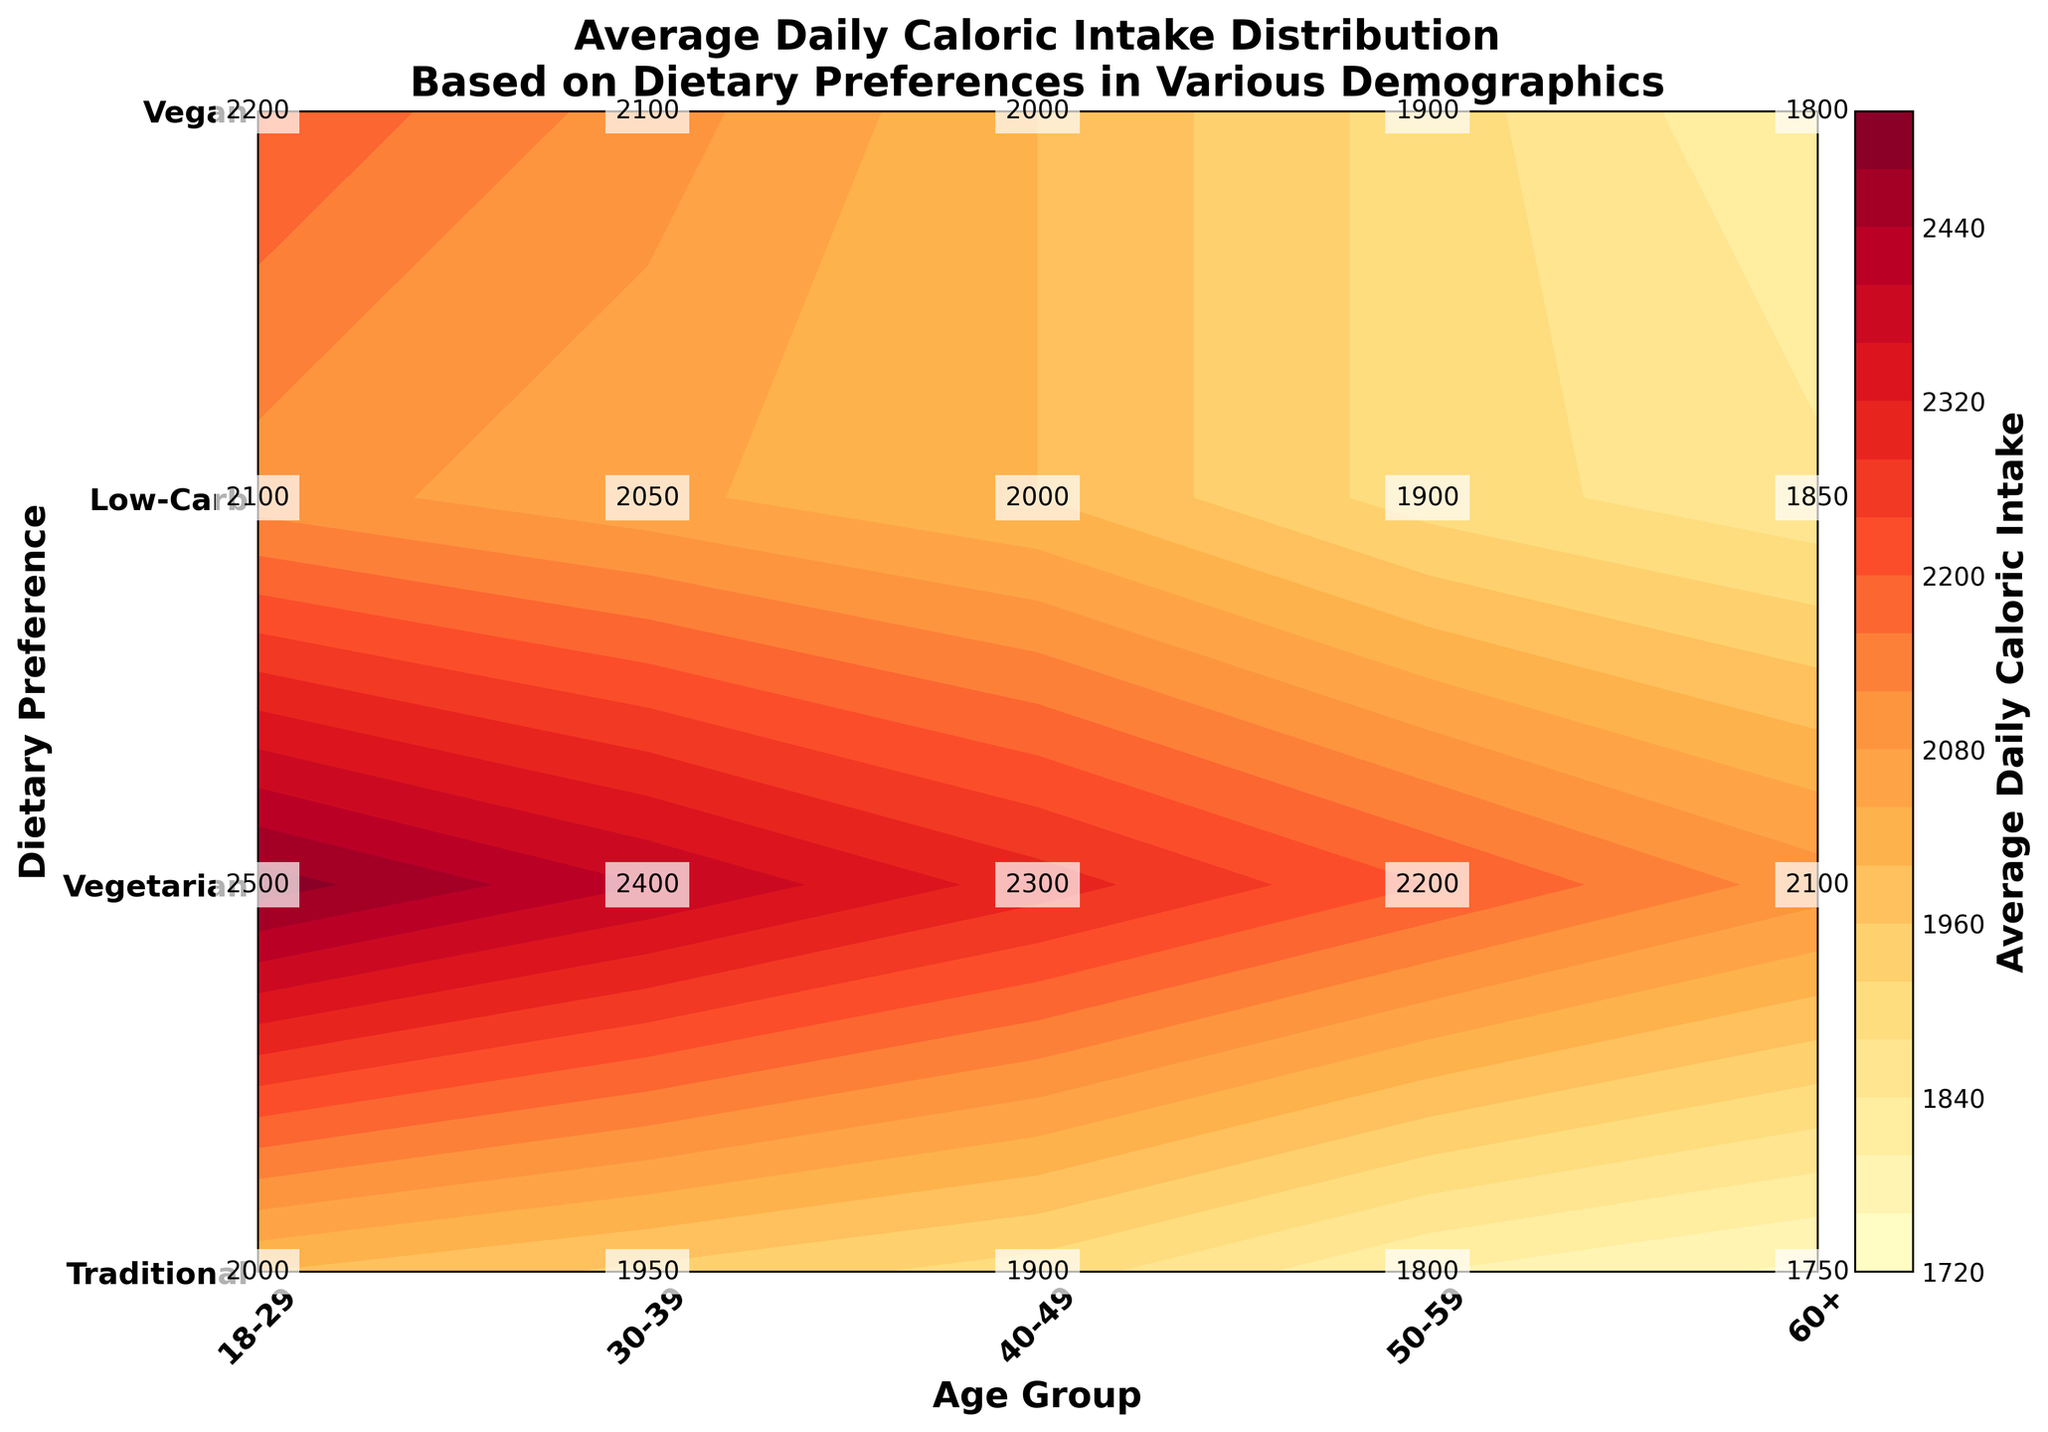What is the average daily caloric intake for the 18-29 age group following a traditional diet? Locate the intersection of the '18-29' age group on the x-axis and the 'Traditional' dietary preference on the y-axis, and note the caloric value displayed there.
Answer: 2500 Which age group has the lowest average daily caloric intake for those following a low-carb diet? Check the values for the 'Low-Carb' dietary preference across all age groups and identify the smallest value.
Answer: 60+ What is the difference in average daily caloric intake between the 30-39 and 40-49 age groups for a vegan diet? Locate the caloric values for the 'Vegan' dietary preference at '30-39' and '40-49' age groups and subtract the latter from the former.
Answer: 50 (2050 - 2000 = 50) How does the average daily caloric intake for the traditional diet change across different age groups? Observe the contour labels for 'Traditional' across the '18-29', '30-39', '40-49', '50-59', and '60+' age groups and note the caloric intake values and their trends.
Answer: Decreases from 2500 to 2100 as age increases For the 40-49 age group, which dietary preference has the highest caloric intake? Look at the values under the '40-49' age group for all dietary preferences and identify the largest value.
Answer: Traditional (2300) What is the average daily caloric intake for vegetarians across all age groups? Sum the caloric values across all age groups under the 'Vegetarian' dietary preference and divide by the number of age groups (5). Calculation: (2200 + 2100 + 2000 + 1900 + 1800) / 5
Answer: 2000 Which dietary preference shows the most significant decrease in average daily caloric intake from the 18-29 age group to the 60+ age group? Calculate the difference in average daily caloric intake between the '18-29' and '60+' age groups for each dietary preference and identify the largest decrease.
Answer: Traditional (400 kcal decrease) What is the average daily caloric intake for the vegetarian and vegan diets for the 50-59 age group? Locate the values for the 'Vegetarian' and 'Vegan' dietary preferences under the '50-59' age group and calculate their average. Calculation: (1900 + 1900) / 2
Answer: 1900 